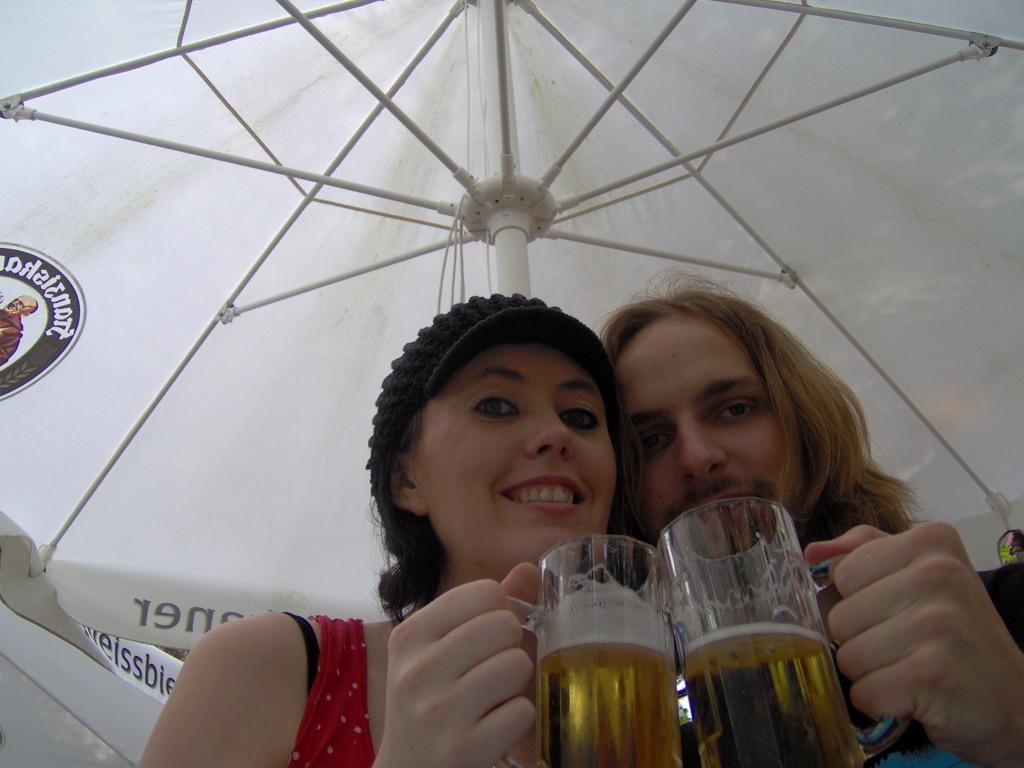Please provide a concise description of this image. In this image, there are two persons standing and holding a glass, who are half visible and both are under the umbrella tent. This image is taken inside a hut. 